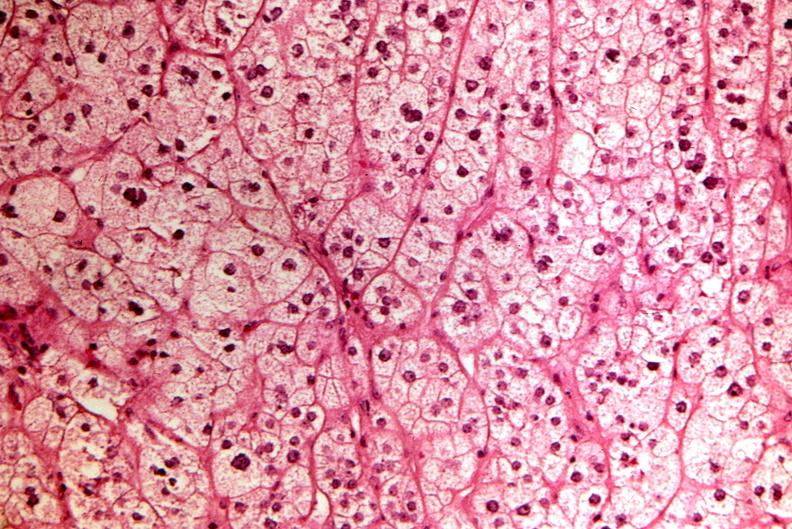what does this image show?
Answer the question using a single word or phrase. Pituitary 